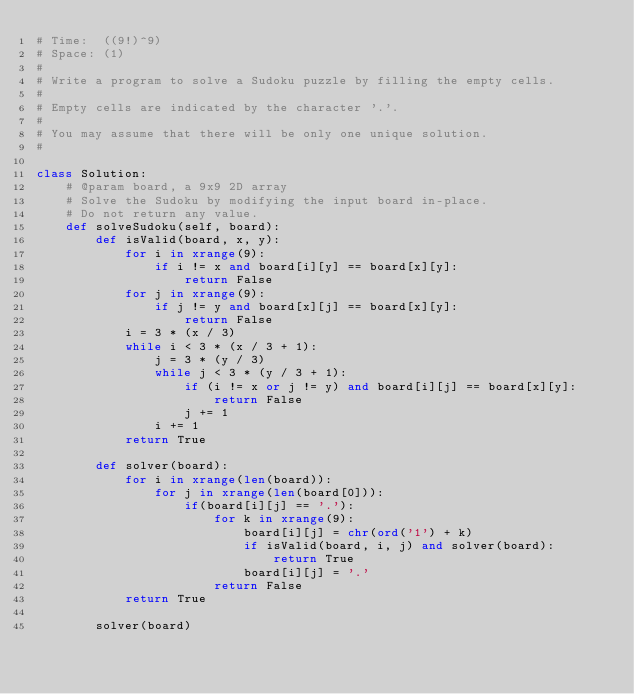<code> <loc_0><loc_0><loc_500><loc_500><_Python_># Time:  ((9!)^9)
# Space: (1)
#
# Write a program to solve a Sudoku puzzle by filling the empty cells.
# 
# Empty cells are indicated by the character '.'.
# 
# You may assume that there will be only one unique solution.
#

class Solution:
    # @param board, a 9x9 2D array
    # Solve the Sudoku by modifying the input board in-place.
    # Do not return any value.
    def solveSudoku(self, board):
        def isValid(board, x, y):
            for i in xrange(9):
                if i != x and board[i][y] == board[x][y]:
                    return False
            for j in xrange(9):
                if j != y and board[x][j] == board[x][y]:
                    return False
            i = 3 * (x / 3)
            while i < 3 * (x / 3 + 1):
                j = 3 * (y / 3)
                while j < 3 * (y / 3 + 1):
                    if (i != x or j != y) and board[i][j] == board[x][y]:
                        return False
                    j += 1
                i += 1
            return True
        
        def solver(board):
            for i in xrange(len(board)):
                for j in xrange(len(board[0])):
                    if(board[i][j] == '.'):
                        for k in xrange(9):
                            board[i][j] = chr(ord('1') + k)
                            if isValid(board, i, j) and solver(board):
                                return True
                            board[i][j] = '.'
                        return False
            return True

        solver(board)
</code> 